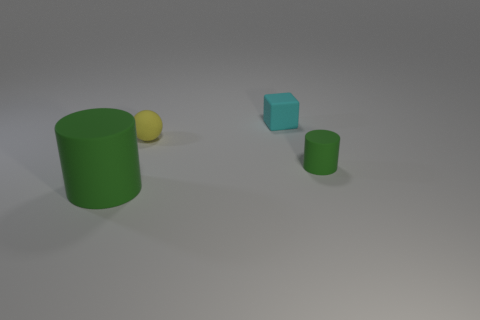Does the large cylinder have the same color as the small cylinder?
Provide a succinct answer. Yes. Are any spheres visible?
Keep it short and to the point. Yes. Are there more small matte blocks behind the small cyan thing than spheres that are right of the small yellow matte thing?
Provide a short and direct response. No. The matte cylinder that is behind the green rubber cylinder that is on the left side of the yellow rubber object is what color?
Provide a short and direct response. Green. Is there a small rubber cylinder that has the same color as the big rubber cylinder?
Make the answer very short. Yes. What is the size of the yellow rubber object that is on the left side of the green thing to the right of the green cylinder left of the small green matte thing?
Your answer should be compact. Small. The small cyan rubber thing has what shape?
Your answer should be very brief. Cube. There is another thing that is the same color as the large rubber object; what size is it?
Keep it short and to the point. Small. There is a object behind the ball; what number of cyan cubes are behind it?
Your answer should be compact. 0. What number of other things are the same material as the small ball?
Offer a very short reply. 3. 